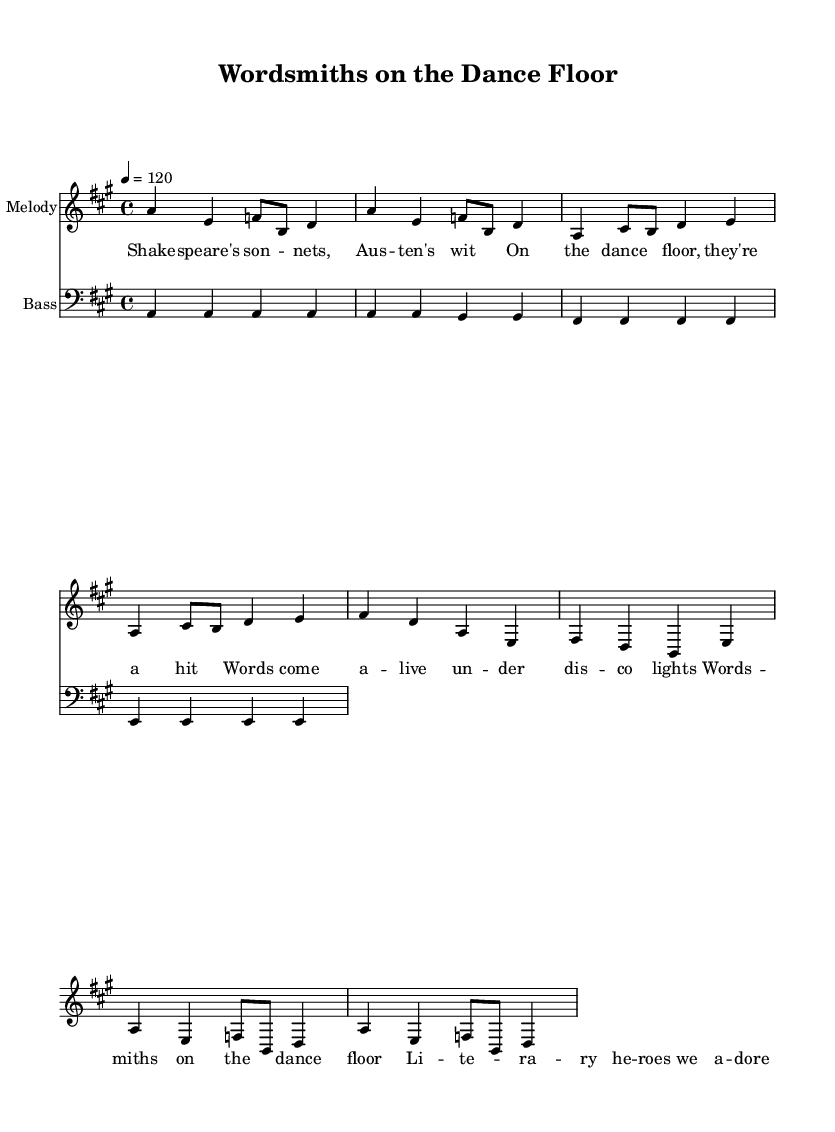What is the key signature of this music? The key signature is A major, which has three sharps: F sharp, C sharp, and G sharp. This can be identified by looking at the key signature notation at the beginning of the score.
Answer: A major What is the time signature of this piece? The time signature is 4/4, meaning there are four beats in each measure and the quarter note gets one beat. This is indicated at the start of the music.
Answer: 4/4 What is the tempo marking of the song? The tempo marking is quarter note equals 120 beats per minute, which instructs the performer to play at a moderate speed. This is stated at the beginning of the score with "4 = 120."
Answer: 120 In which section do Shakespeare and Austen appear? Shakespeare and Austen appear in the verse section of the lyrics, as indicated by their names being part of the text outlined in the verse.
Answer: Verse How many measures are there in the chorus? There are 2 measures in the chorus. The chorus is a repeated section identified at the same location in the music as the melody structure. Counting the measures gives the total.
Answer: 2 What is the chord quality suggested by the bass line for the first measure? The bass line in the first measure suggests an A major chord, as the bass note A corresponds with the melody notes which also imply the A major tonality.
Answer: A major Which literary heroes are mentioned in the lyrics? The lyrics mention "Shakespeare" and "Austen" as literary heroes celebrated in the song. These names are clearly referenced in the verse of the music.
Answer: Shakespeare, Austen 